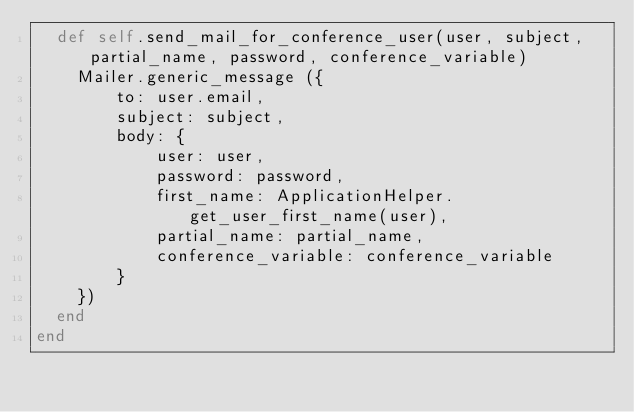Convert code to text. <code><loc_0><loc_0><loc_500><loc_500><_Ruby_>  def self.send_mail_for_conference_user(user, subject, partial_name, password, conference_variable)
    Mailer.generic_message ({
        to: user.email,
        subject: subject,
        body: {
            user: user,
            password: password,
            first_name: ApplicationHelper.get_user_first_name(user),
            partial_name: partial_name,
            conference_variable: conference_variable
        }
    })
  end
end
</code> 